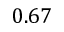<formula> <loc_0><loc_0><loc_500><loc_500>0 . 6 7</formula> 